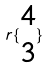<formula> <loc_0><loc_0><loc_500><loc_500>r \{ \begin{matrix} 4 \\ 3 \end{matrix} \}</formula> 